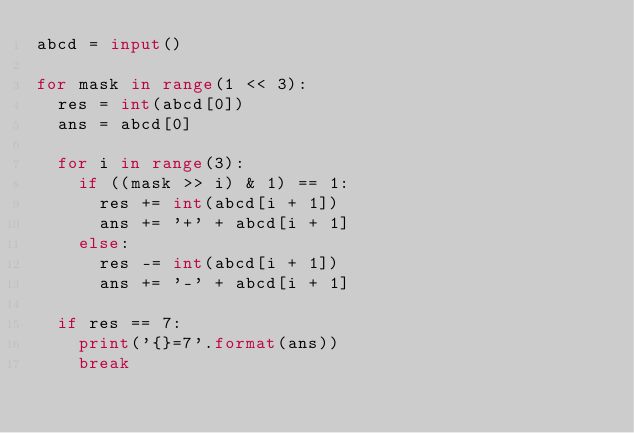Convert code to text. <code><loc_0><loc_0><loc_500><loc_500><_Python_>abcd = input()

for mask in range(1 << 3):
  res = int(abcd[0])
  ans = abcd[0]
  
  for i in range(3):
    if ((mask >> i) & 1) == 1:
      res += int(abcd[i + 1])
      ans += '+' + abcd[i + 1]
    else:
      res -= int(abcd[i + 1])
      ans += '-' + abcd[i + 1]
  
  if res == 7:
    print('{}=7'.format(ans))
    break</code> 